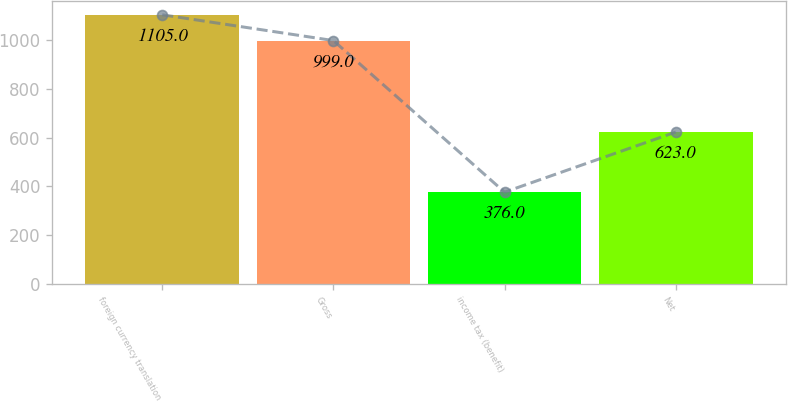Convert chart. <chart><loc_0><loc_0><loc_500><loc_500><bar_chart><fcel>foreign currency translation<fcel>Gross<fcel>income tax (benefit)<fcel>Net<nl><fcel>1105<fcel>999<fcel>376<fcel>623<nl></chart> 